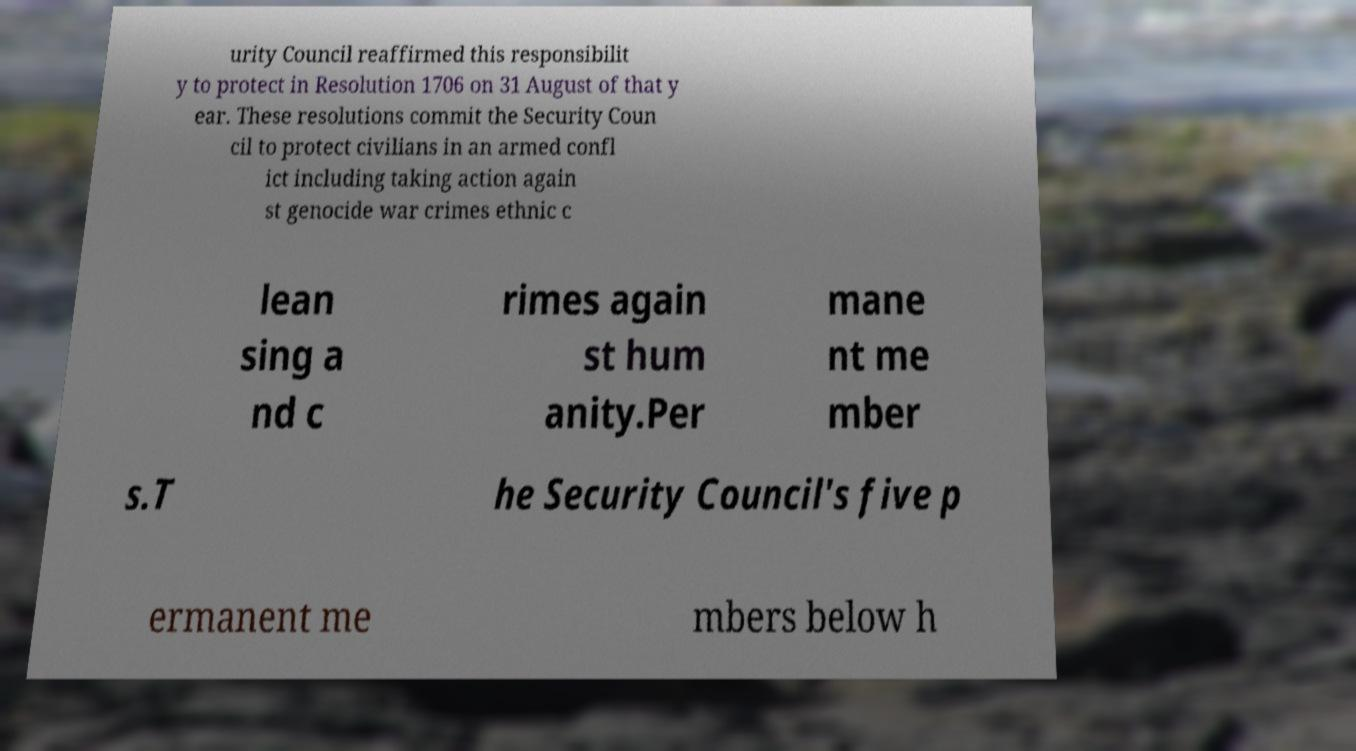Could you assist in decoding the text presented in this image and type it out clearly? urity Council reaffirmed this responsibilit y to protect in Resolution 1706 on 31 August of that y ear. These resolutions commit the Security Coun cil to protect civilians in an armed confl ict including taking action again st genocide war crimes ethnic c lean sing a nd c rimes again st hum anity.Per mane nt me mber s.T he Security Council's five p ermanent me mbers below h 